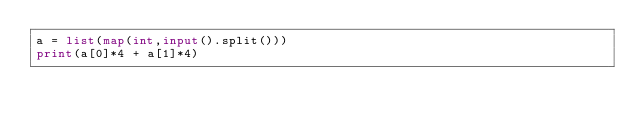Convert code to text. <code><loc_0><loc_0><loc_500><loc_500><_Python_>a = list(map(int,input().split()))
print(a[0]*4 + a[1]*4)</code> 